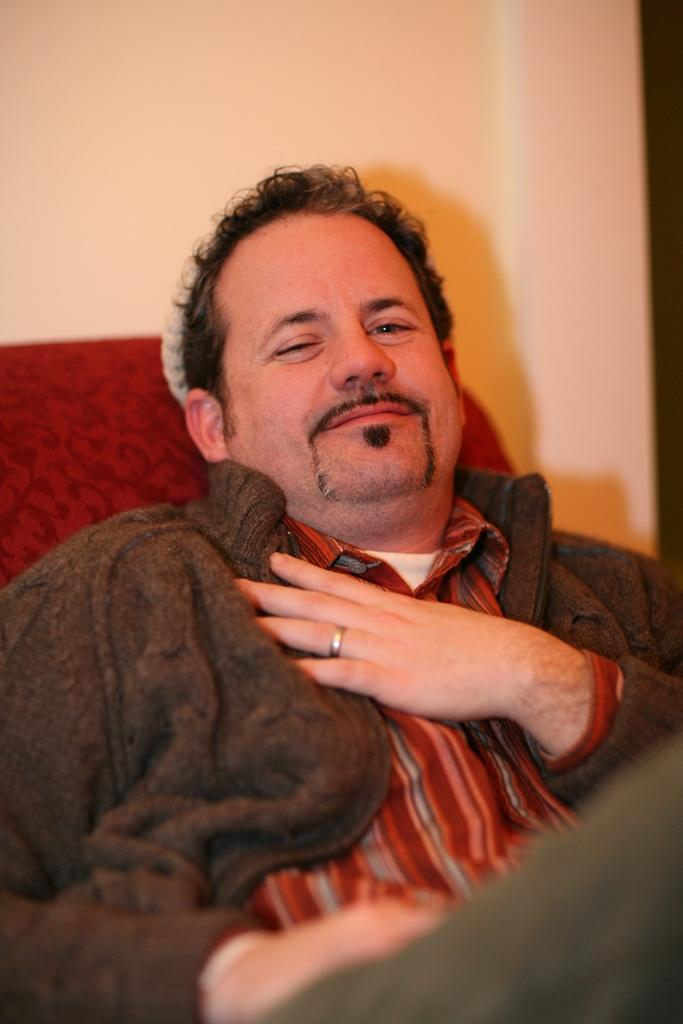What is the person in the image doing? The person is sitting in the image. Where is the person located in relation to the image? The person is at the bottom of the image. What type of furniture is on the left side of the image? There is a red sofa on the left side of the image. What can be seen in the background of the image? There is a wall in the background of the image. How many cakes are on the toy scale in the image? There is no toy scale or cakes present in the image. 